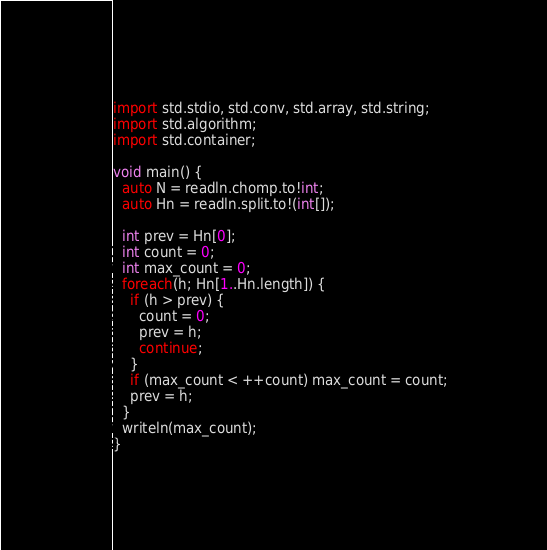<code> <loc_0><loc_0><loc_500><loc_500><_D_>import std.stdio, std.conv, std.array, std.string;
import std.algorithm;
import std.container;

void main() {
  auto N = readln.chomp.to!int;
  auto Hn = readln.split.to!(int[]);

  int prev = Hn[0];
  int count = 0;
  int max_count = 0;
  foreach(h; Hn[1..Hn.length]) {
    if (h > prev) {
      count = 0;
      prev = h;
      continue;
    }
    if (max_count < ++count) max_count = count;
    prev = h;
  }
  writeln(max_count);
}
</code> 